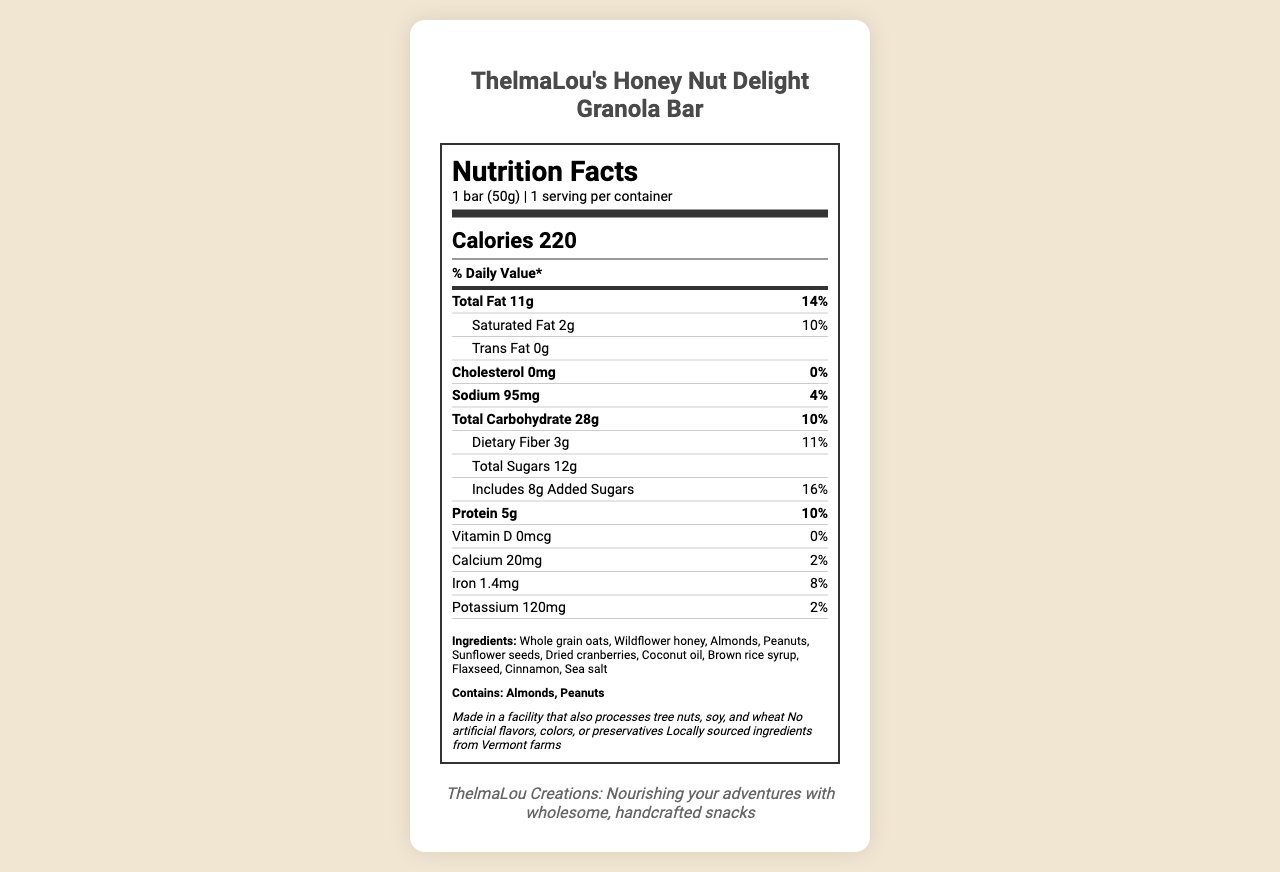what is the serving size? The second line of the document specifies the serving size as "1 bar (50g)."
Answer: 1 bar (50g) how many calories are in one serving of the granola bar? The document mentions "Calories 220" in the calorie information section.
Answer: 220 how much total fat is in the granola bar? The total fat content is listed under the "Total Fat" nutrient row.
Answer: 11g What percentage of the daily value for saturated fat does one serving of the granola bar contain? The "Saturated Fat" section lists the daily value as 10%.
Answer: 10% how many grams of dietary fiber are in the granola bar? The amount of dietary fiber is specified as 3g in the nutrient rows.
Answer: 3g How many grams of total sugars are in the granola bar? The total sugars are indicated to be 12g in the sub-nutrient section.
Answer: 12g What are the main allergens present in the granola bar? The "allergens" section notes that the product contains almonds and peanuts.
Answer: Almonds, Peanuts Does the granola bar contain any artificial flavors, colors, or preservatives? The additional information states, "No artificial flavors, colors, or preservatives."
Answer: No Which of the following vitamins and minerals are present in the granola bar?
A. Vitamin C
B. Calcium
C. Vitamin B12
D. Iron The document lists calcium (20mg) and iron (1.4mg) in the nutrient section, but not Vitamin C or Vitamin B12.
Answer: B. Calcium Which nutrient has a higher daily value percentage in this granola bar?
I. Cholesterol
II. Sodium
III. Protein Cholesterol has 0% daily value, sodium has 4% daily value, and protein has 10% daily value.
Answer: III. Protein Is the granola bar made in a facility that processes soy? The additional information states, "Made in a facility that also processes tree nuts, soy, and wheat."
Answer: Yes What is the brand's mission statement? The brand statement at the bottom of the document provides this information clearly.
Answer: ThelmaLou Creations: Nourishing your adventures with wholesome, handcrafted snacks Provide a summary of the nutritional content and additional information of ThelmaLou's Honey Nut Delight Granola Bar. This summary encompasses both the nutritional facts provided and key additional information, including allergens and production details.
Answer: The document details the nutritional content for one 50g bar of ThelmaLou's Honey Nut Delight Granola Bar. It contains 220 calories, 11g of total fat, 2g of saturated fat, 0g of trans fat, 0mg of cholesterol, 95mg of sodium, 28g of total carbohydrate, 3g of dietary fiber, 12g of total sugars (including 8g of added sugars), and 5g of protein. Vitamins and minerals include 0mcg of vitamin D, 20mg of calcium, 1.4mg of iron, and 120mg of potassium. The ingredients list includes whole grain oats, wildflower honey, and other natural ingredients. The bar is made in a facility that processes tree nuts, soy, and wheat and contains no artificial flavors, colors, or preservatives. Is the granola bar suitable for someone who is allergic to tree nuts? While the granola bar contains almonds and peanuts, it is also made in a facility that processes tree nuts. It is unclear whether the specific tree nut an individual may be allergic to is present.
Answer: Not enough information How much protein does the granola bar contain? The protein content is listed as 5g in the nutrient section.
Answer: 5g What amount of added sugars does the granola bar include? The document specifies that the granola bar includes 8g of added sugars.
Answer: 8g 